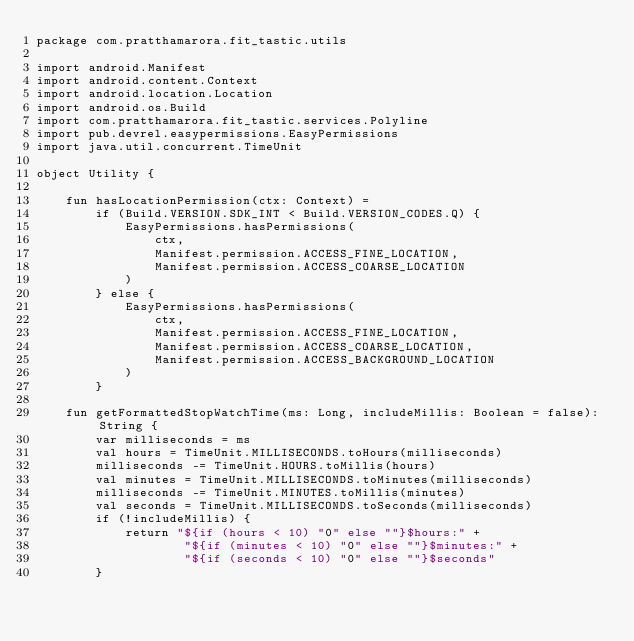<code> <loc_0><loc_0><loc_500><loc_500><_Kotlin_>package com.pratthamarora.fit_tastic.utils

import android.Manifest
import android.content.Context
import android.location.Location
import android.os.Build
import com.pratthamarora.fit_tastic.services.Polyline
import pub.devrel.easypermissions.EasyPermissions
import java.util.concurrent.TimeUnit

object Utility {

    fun hasLocationPermission(ctx: Context) =
        if (Build.VERSION.SDK_INT < Build.VERSION_CODES.Q) {
            EasyPermissions.hasPermissions(
                ctx,
                Manifest.permission.ACCESS_FINE_LOCATION,
                Manifest.permission.ACCESS_COARSE_LOCATION
            )
        } else {
            EasyPermissions.hasPermissions(
                ctx,
                Manifest.permission.ACCESS_FINE_LOCATION,
                Manifest.permission.ACCESS_COARSE_LOCATION,
                Manifest.permission.ACCESS_BACKGROUND_LOCATION
            )
        }

    fun getFormattedStopWatchTime(ms: Long, includeMillis: Boolean = false): String {
        var milliseconds = ms
        val hours = TimeUnit.MILLISECONDS.toHours(milliseconds)
        milliseconds -= TimeUnit.HOURS.toMillis(hours)
        val minutes = TimeUnit.MILLISECONDS.toMinutes(milliseconds)
        milliseconds -= TimeUnit.MINUTES.toMillis(minutes)
        val seconds = TimeUnit.MILLISECONDS.toSeconds(milliseconds)
        if (!includeMillis) {
            return "${if (hours < 10) "0" else ""}$hours:" +
                    "${if (minutes < 10) "0" else ""}$minutes:" +
                    "${if (seconds < 10) "0" else ""}$seconds"
        }</code> 